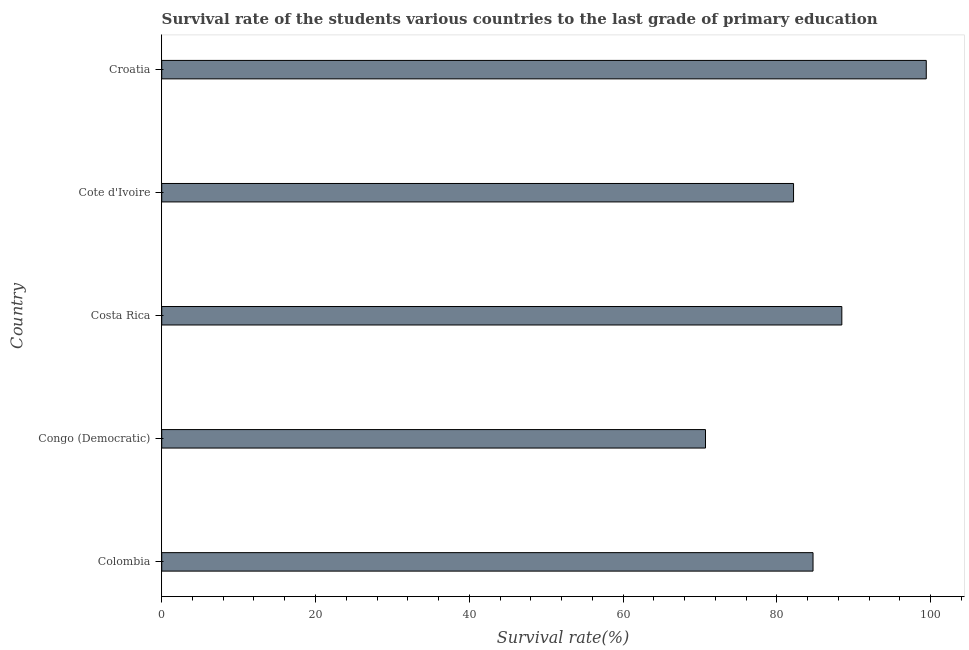Does the graph contain grids?
Keep it short and to the point. No. What is the title of the graph?
Give a very brief answer. Survival rate of the students various countries to the last grade of primary education. What is the label or title of the X-axis?
Keep it short and to the point. Survival rate(%). What is the survival rate in primary education in Croatia?
Your response must be concise. 99.44. Across all countries, what is the maximum survival rate in primary education?
Your response must be concise. 99.44. Across all countries, what is the minimum survival rate in primary education?
Make the answer very short. 70.73. In which country was the survival rate in primary education maximum?
Give a very brief answer. Croatia. In which country was the survival rate in primary education minimum?
Your response must be concise. Congo (Democratic). What is the sum of the survival rate in primary education?
Your answer should be compact. 425.51. What is the difference between the survival rate in primary education in Costa Rica and Croatia?
Keep it short and to the point. -10.98. What is the average survival rate in primary education per country?
Your answer should be very brief. 85.1. What is the median survival rate in primary education?
Your answer should be very brief. 84.71. What is the ratio of the survival rate in primary education in Colombia to that in Congo (Democratic)?
Give a very brief answer. 1.2. Is the difference between the survival rate in primary education in Colombia and Costa Rica greater than the difference between any two countries?
Provide a short and direct response. No. What is the difference between the highest and the second highest survival rate in primary education?
Your response must be concise. 10.98. Is the sum of the survival rate in primary education in Congo (Democratic) and Croatia greater than the maximum survival rate in primary education across all countries?
Offer a very short reply. Yes. What is the difference between the highest and the lowest survival rate in primary education?
Offer a very short reply. 28.71. In how many countries, is the survival rate in primary education greater than the average survival rate in primary education taken over all countries?
Make the answer very short. 2. Are all the bars in the graph horizontal?
Offer a very short reply. Yes. How many countries are there in the graph?
Your answer should be very brief. 5. What is the Survival rate(%) of Colombia?
Provide a short and direct response. 84.71. What is the Survival rate(%) in Congo (Democratic)?
Offer a very short reply. 70.73. What is the Survival rate(%) in Costa Rica?
Make the answer very short. 88.46. What is the Survival rate(%) of Cote d'Ivoire?
Ensure brevity in your answer.  82.18. What is the Survival rate(%) in Croatia?
Your response must be concise. 99.44. What is the difference between the Survival rate(%) in Colombia and Congo (Democratic)?
Give a very brief answer. 13.99. What is the difference between the Survival rate(%) in Colombia and Costa Rica?
Ensure brevity in your answer.  -3.75. What is the difference between the Survival rate(%) in Colombia and Cote d'Ivoire?
Your answer should be very brief. 2.53. What is the difference between the Survival rate(%) in Colombia and Croatia?
Ensure brevity in your answer.  -14.73. What is the difference between the Survival rate(%) in Congo (Democratic) and Costa Rica?
Your answer should be very brief. -17.73. What is the difference between the Survival rate(%) in Congo (Democratic) and Cote d'Ivoire?
Offer a very short reply. -11.45. What is the difference between the Survival rate(%) in Congo (Democratic) and Croatia?
Offer a terse response. -28.71. What is the difference between the Survival rate(%) in Costa Rica and Cote d'Ivoire?
Your answer should be compact. 6.28. What is the difference between the Survival rate(%) in Costa Rica and Croatia?
Your response must be concise. -10.98. What is the difference between the Survival rate(%) in Cote d'Ivoire and Croatia?
Your response must be concise. -17.26. What is the ratio of the Survival rate(%) in Colombia to that in Congo (Democratic)?
Your answer should be compact. 1.2. What is the ratio of the Survival rate(%) in Colombia to that in Costa Rica?
Provide a short and direct response. 0.96. What is the ratio of the Survival rate(%) in Colombia to that in Cote d'Ivoire?
Offer a very short reply. 1.03. What is the ratio of the Survival rate(%) in Colombia to that in Croatia?
Your answer should be very brief. 0.85. What is the ratio of the Survival rate(%) in Congo (Democratic) to that in Costa Rica?
Your answer should be very brief. 0.8. What is the ratio of the Survival rate(%) in Congo (Democratic) to that in Cote d'Ivoire?
Provide a succinct answer. 0.86. What is the ratio of the Survival rate(%) in Congo (Democratic) to that in Croatia?
Your response must be concise. 0.71. What is the ratio of the Survival rate(%) in Costa Rica to that in Cote d'Ivoire?
Make the answer very short. 1.08. What is the ratio of the Survival rate(%) in Costa Rica to that in Croatia?
Provide a short and direct response. 0.89. What is the ratio of the Survival rate(%) in Cote d'Ivoire to that in Croatia?
Give a very brief answer. 0.83. 